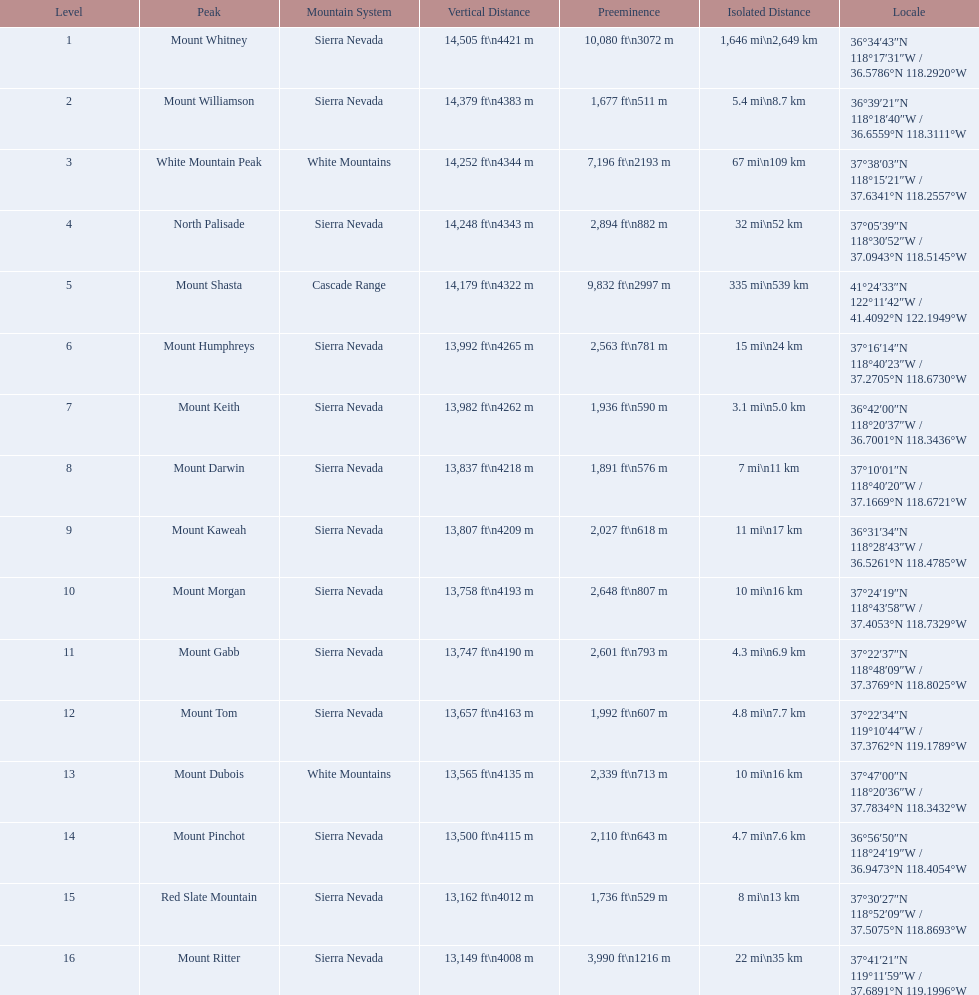What are the heights of the californian mountain peaks? 14,505 ft\n4421 m, 14,379 ft\n4383 m, 14,252 ft\n4344 m, 14,248 ft\n4343 m, 14,179 ft\n4322 m, 13,992 ft\n4265 m, 13,982 ft\n4262 m, 13,837 ft\n4218 m, 13,807 ft\n4209 m, 13,758 ft\n4193 m, 13,747 ft\n4190 m, 13,657 ft\n4163 m, 13,565 ft\n4135 m, 13,500 ft\n4115 m, 13,162 ft\n4012 m, 13,149 ft\n4008 m. What elevation is 13,149 ft or less? 13,149 ft\n4008 m. What mountain peak is at this elevation? Mount Ritter. 